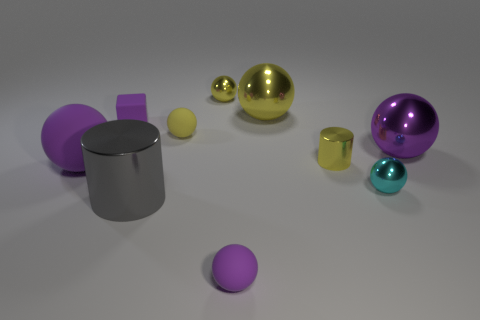Subtract all yellow spheres. How many were subtracted if there are1yellow spheres left? 2 Subtract all yellow cylinders. How many purple spheres are left? 3 Subtract 3 balls. How many balls are left? 4 Subtract all purple balls. How many balls are left? 4 Subtract all large purple spheres. How many spheres are left? 5 Subtract all brown spheres. Subtract all gray cylinders. How many spheres are left? 7 Subtract all cylinders. How many objects are left? 8 Add 7 large yellow spheres. How many large yellow spheres exist? 8 Subtract 0 green balls. How many objects are left? 10 Subtract all yellow metallic things. Subtract all large yellow shiny balls. How many objects are left? 6 